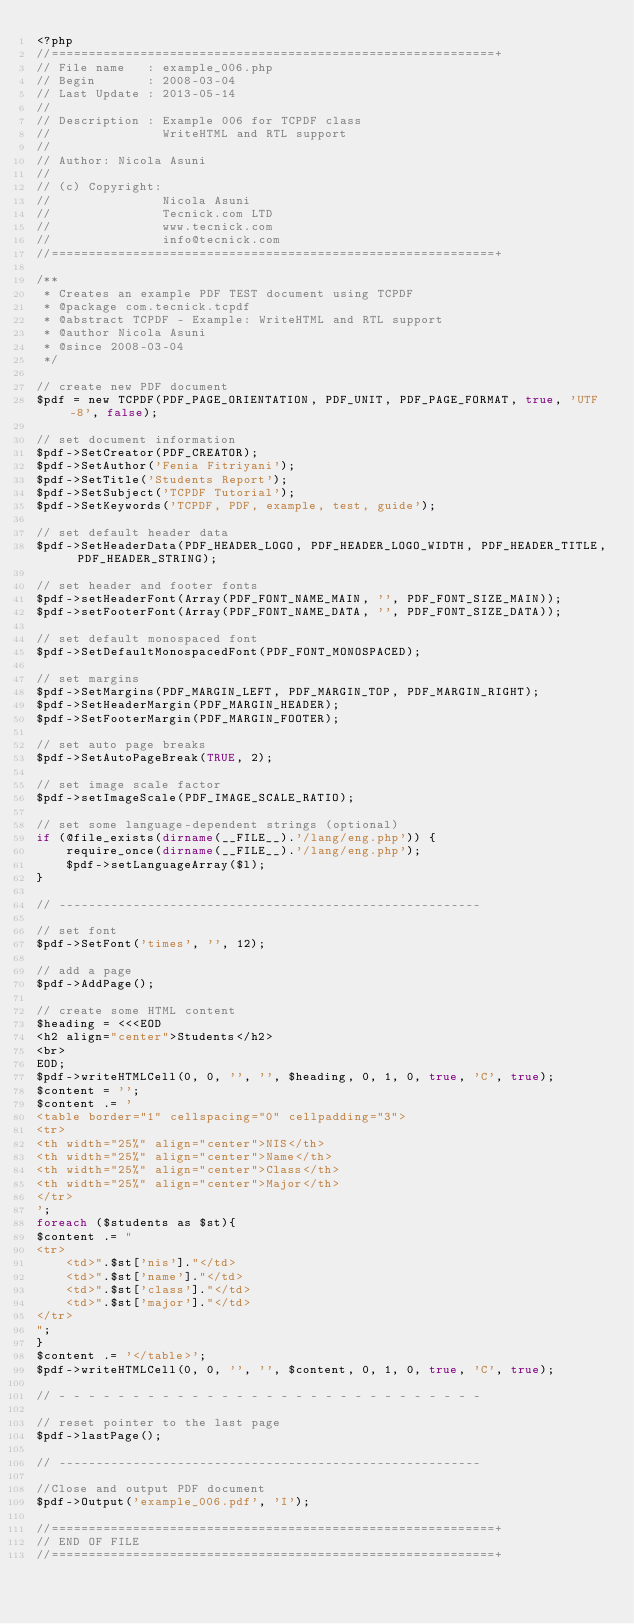<code> <loc_0><loc_0><loc_500><loc_500><_PHP_><?php
//============================================================+
// File name   : example_006.php
// Begin       : 2008-03-04
// Last Update : 2013-05-14
//
// Description : Example 006 for TCPDF class
//               WriteHTML and RTL support
//
// Author: Nicola Asuni
//
// (c) Copyright:
//               Nicola Asuni
//               Tecnick.com LTD
//               www.tecnick.com
//               info@tecnick.com
//============================================================+

/**
 * Creates an example PDF TEST document using TCPDF
 * @package com.tecnick.tcpdf
 * @abstract TCPDF - Example: WriteHTML and RTL support
 * @author Nicola Asuni
 * @since 2008-03-04
 */

// create new PDF document
$pdf = new TCPDF(PDF_PAGE_ORIENTATION, PDF_UNIT, PDF_PAGE_FORMAT, true, 'UTF-8', false);

// set document information
$pdf->SetCreator(PDF_CREATOR);
$pdf->SetAuthor('Fenia Fitriyani');
$pdf->SetTitle('Students Report');
$pdf->SetSubject('TCPDF Tutorial');
$pdf->SetKeywords('TCPDF, PDF, example, test, guide');

// set default header data
$pdf->SetHeaderData(PDF_HEADER_LOGO, PDF_HEADER_LOGO_WIDTH, PDF_HEADER_TITLE, PDF_HEADER_STRING);

// set header and footer fonts
$pdf->setHeaderFont(Array(PDF_FONT_NAME_MAIN, '', PDF_FONT_SIZE_MAIN));
$pdf->setFooterFont(Array(PDF_FONT_NAME_DATA, '', PDF_FONT_SIZE_DATA));

// set default monospaced font
$pdf->SetDefaultMonospacedFont(PDF_FONT_MONOSPACED);

// set margins
$pdf->SetMargins(PDF_MARGIN_LEFT, PDF_MARGIN_TOP, PDF_MARGIN_RIGHT);
$pdf->SetHeaderMargin(PDF_MARGIN_HEADER);
$pdf->SetFooterMargin(PDF_MARGIN_FOOTER);

// set auto page breaks
$pdf->SetAutoPageBreak(TRUE, 2);

// set image scale factor
$pdf->setImageScale(PDF_IMAGE_SCALE_RATIO);

// set some language-dependent strings (optional)
if (@file_exists(dirname(__FILE__).'/lang/eng.php')) {
	require_once(dirname(__FILE__).'/lang/eng.php');
	$pdf->setLanguageArray($l);
}

// ---------------------------------------------------------

// set font
$pdf->SetFont('times', '', 12);

// add a page
$pdf->AddPage();

// create some HTML content
$heading = <<<EOD
<h2 align="center">Students</h2>
<br>
EOD;
$pdf->writeHTMLCell(0, 0, '', '', $heading, 0, 1, 0, true, 'C', true);
$content = '';  
$content .= '
<table border="1" cellspacing="0" cellpadding="3">  
<tr>
<th width="25%" align="center">NIS</th>
<th width="25%" align="center">Name</th>
<th width="25%" align="center">Class</th>
<th width="25%" align="center">Major</th>
</tr>  
'; 
foreach ($students as $st){
$content .= "
<tr>
	<td>".$st['nis']."</td>
	<td>".$st['name']."</td>
	<td>".$st['class']."</td>
	<td>".$st['major']."</td>
</tr>
";
}
$content .= '</table>';  
$pdf->writeHTMLCell(0, 0, '', '', $content, 0, 1, 0, true, 'C', true);  

// - - - - - - - - - - - - - - - - - - - - - - - - - - - - -

// reset pointer to the last page
$pdf->lastPage();

// ---------------------------------------------------------

//Close and output PDF document
$pdf->Output('example_006.pdf', 'I');

//============================================================+
// END OF FILE
//============================================================+
</code> 